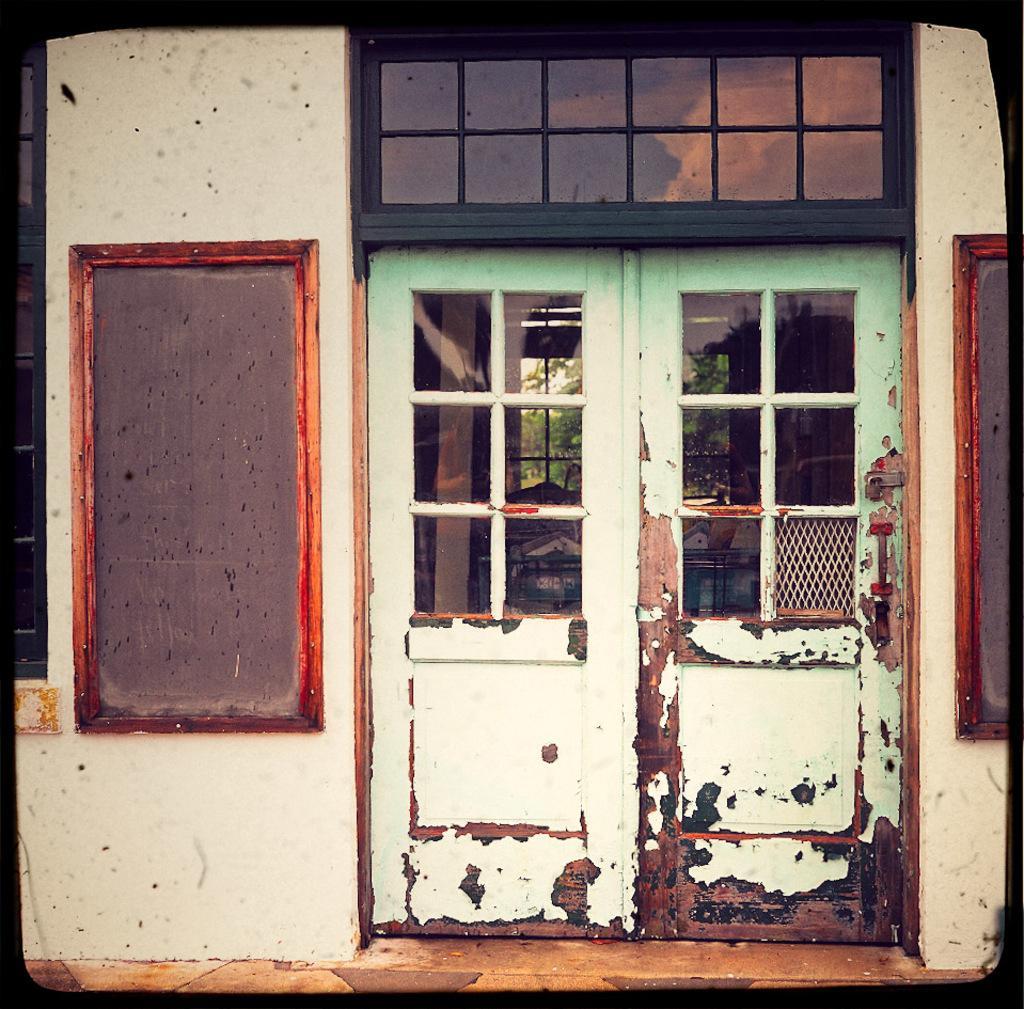Can you describe this image briefly? In this image I can see the doors, window and few boards are attached to the wall. In the background I can see few trees and few objects. 